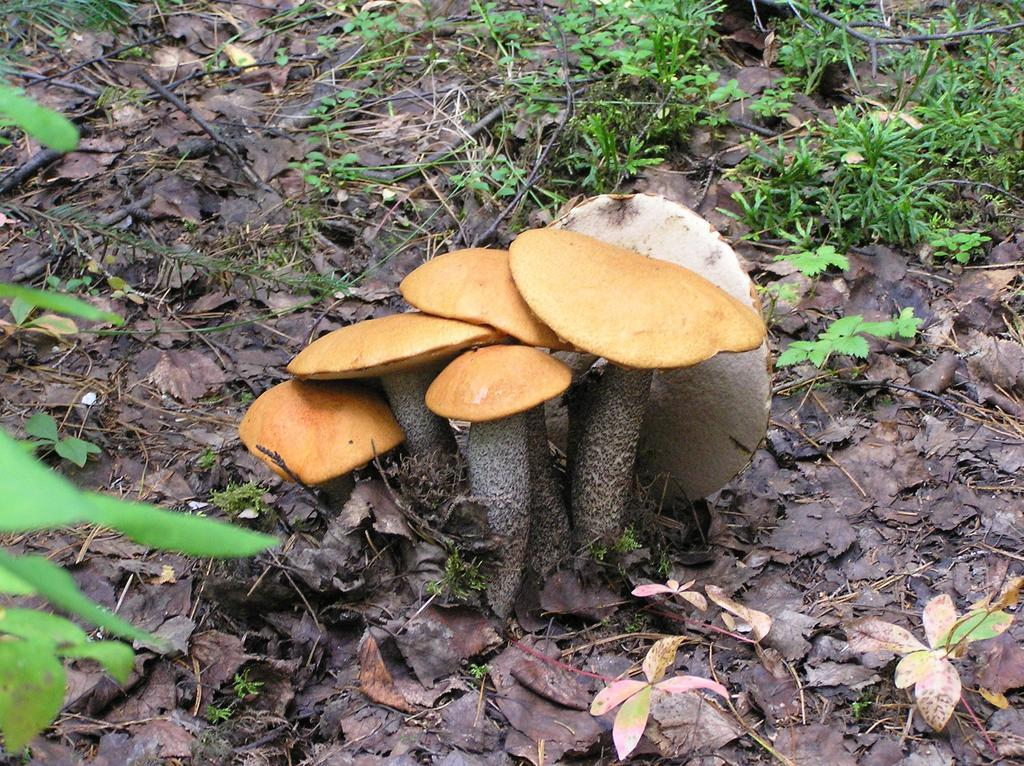What type of fungi can be seen in the image? There are mushrooms in the image. Where are the mushrooms located? The mushrooms are on the land. What is covering the mushrooms? The mushrooms are covered with dry leaves. What other types of vegetation are present in the image? Small plants are present in the image. What type of mine is visible in the image? There is no mine present in the image; it features mushrooms and small plants. How many pins can be seen holding the mushrooms in place? There are no pins present in the image; the mushrooms are covered with dry leaves. 